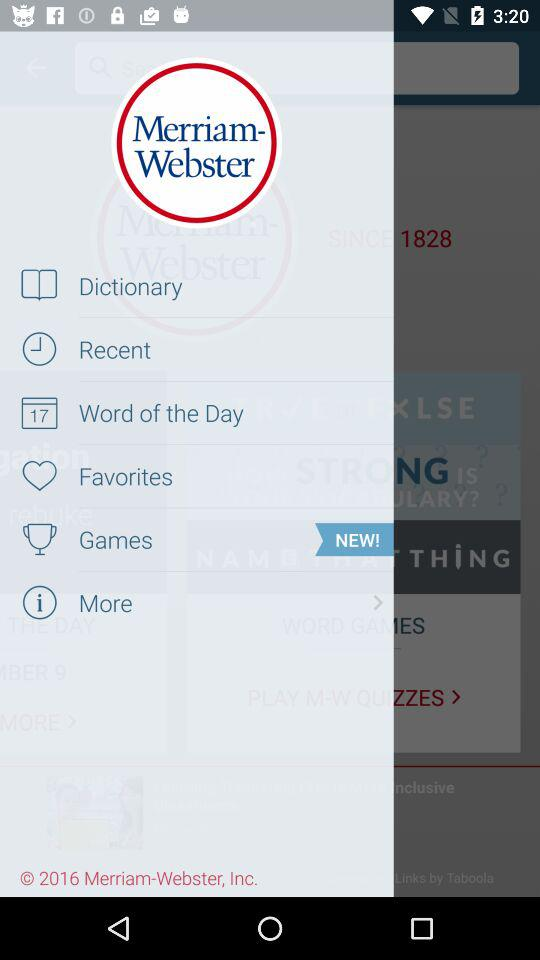What is the date?
When the provided information is insufficient, respond with <no answer>. <no answer> 